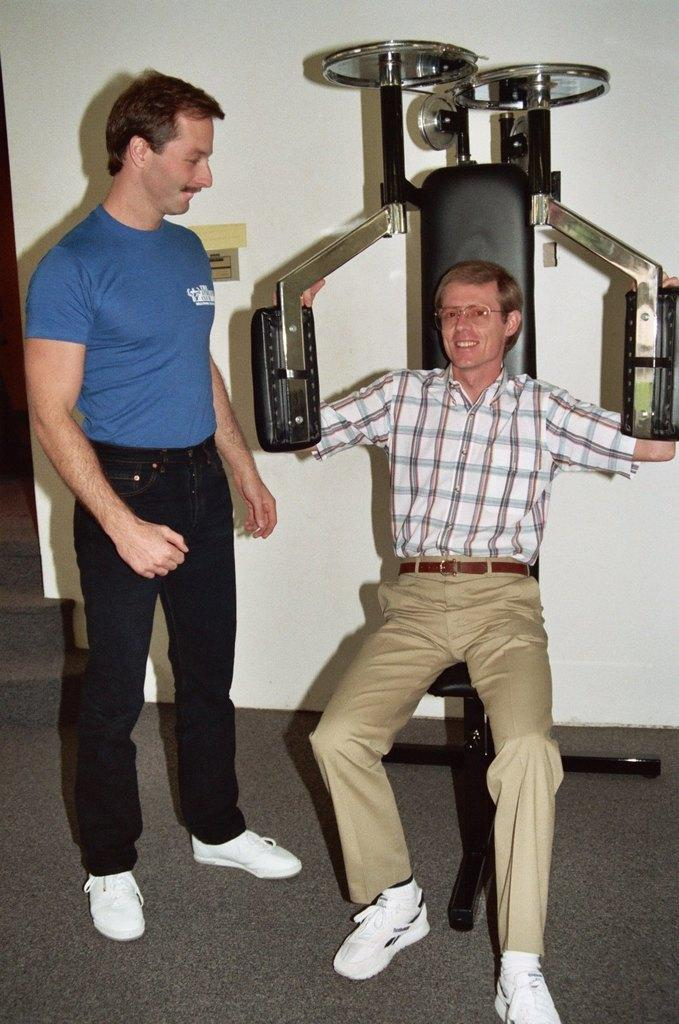How many people are in the image? There are two people in the image. Where are the two people located? The two people are on the floor. What can be seen in the background of the image? There is gym equipment and a wall in the background of the image. What type of locket is the person wearing in the image? There is no locket visible on either person in the image. What historical event is depicted in the image? There is no historical event depicted in the image; it features two people on the floor with gym equipment in the background. 